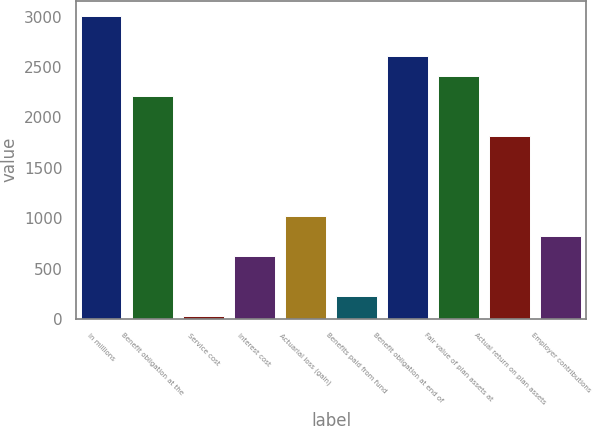<chart> <loc_0><loc_0><loc_500><loc_500><bar_chart><fcel>In millions<fcel>Benefit obligation at the<fcel>Service cost<fcel>Interest cost<fcel>Actuarial loss (gain)<fcel>Benefits paid from fund<fcel>Benefit obligation at end of<fcel>Fair value of plan assets at<fcel>Actual return on plan assets<fcel>Employer contributions<nl><fcel>3009<fcel>2213<fcel>24<fcel>621<fcel>1019<fcel>223<fcel>2611<fcel>2412<fcel>1815<fcel>820<nl></chart> 